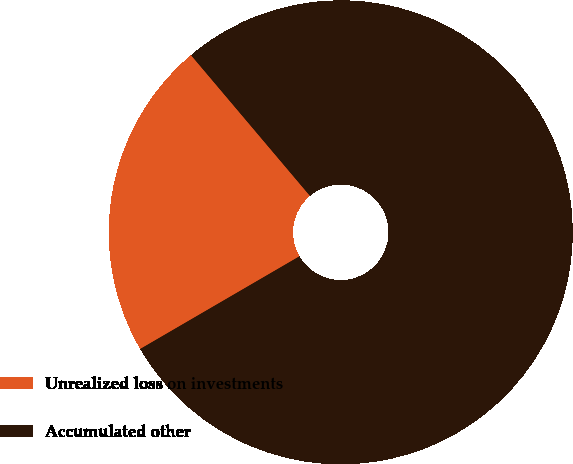Convert chart. <chart><loc_0><loc_0><loc_500><loc_500><pie_chart><fcel>Unrealized loss on investments<fcel>Accumulated other<nl><fcel>22.22%<fcel>77.78%<nl></chart> 